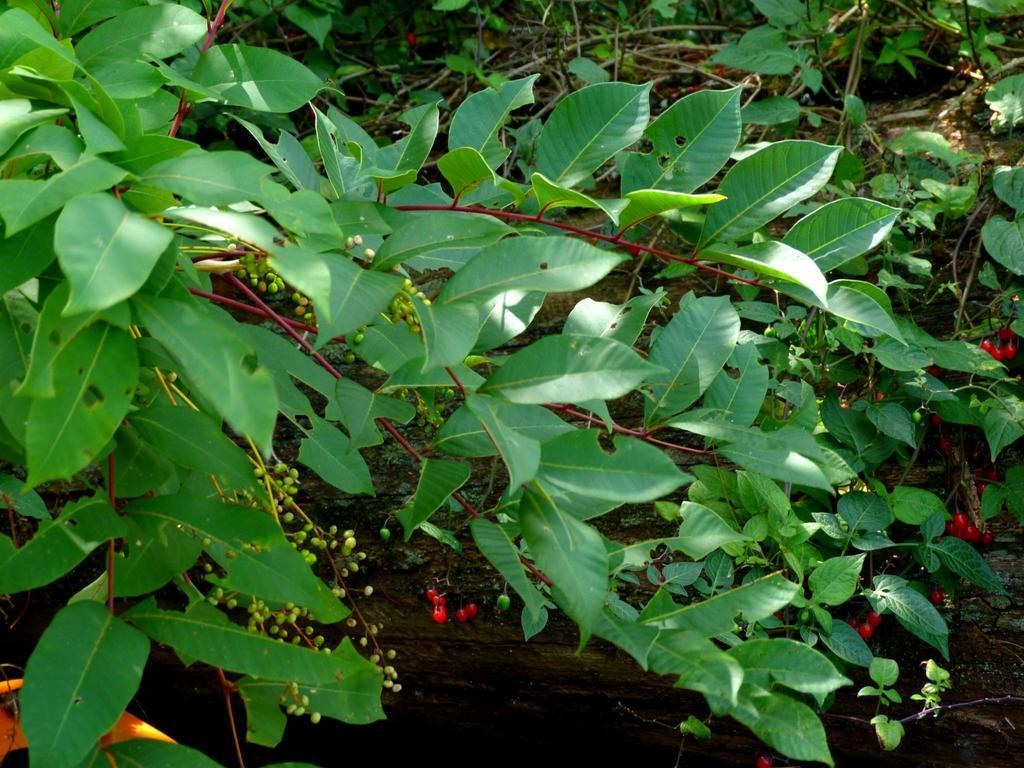What is located in the center of the image? There are trees in the center of the image. What else can be seen in the center of the image? The ground is visible in the center of the image. What type of shoe is hanging from the tree in the image? There is no shoe hanging from the tree in the image; only trees and the ground are present. Is there a fight happening between the trees in the image? There is no fight depicted in the image; it features trees and the ground. 